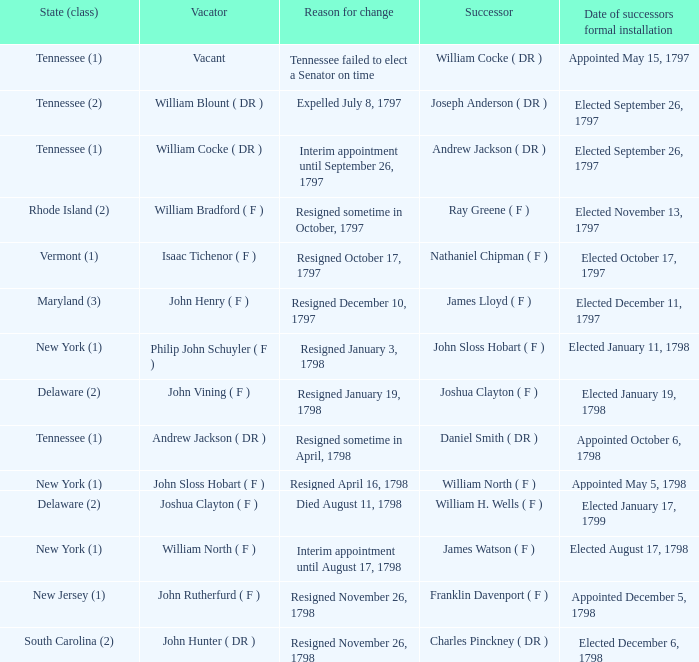What are all the states (class) when the successor was Joseph Anderson ( DR )? Tennessee (2). 